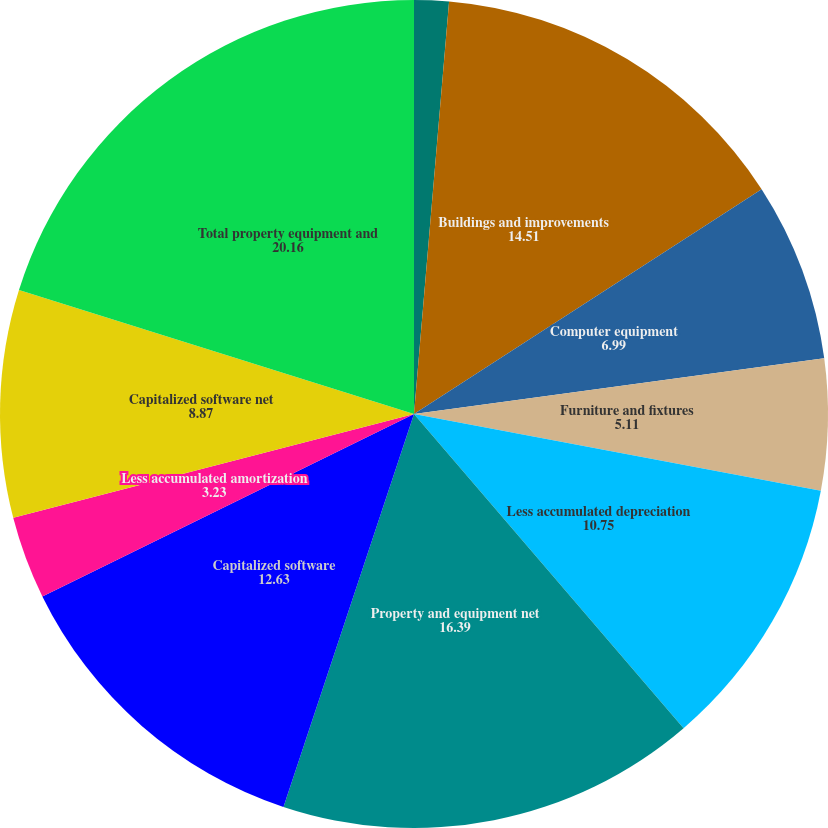Convert chart to OTSL. <chart><loc_0><loc_0><loc_500><loc_500><pie_chart><fcel>Land and improvements<fcel>Buildings and improvements<fcel>Computer equipment<fcel>Furniture and fixtures<fcel>Less accumulated depreciation<fcel>Property and equipment net<fcel>Capitalized software<fcel>Less accumulated amortization<fcel>Capitalized software net<fcel>Total property equipment and<nl><fcel>1.35%<fcel>14.51%<fcel>6.99%<fcel>5.11%<fcel>10.75%<fcel>16.39%<fcel>12.63%<fcel>3.23%<fcel>8.87%<fcel>20.16%<nl></chart> 